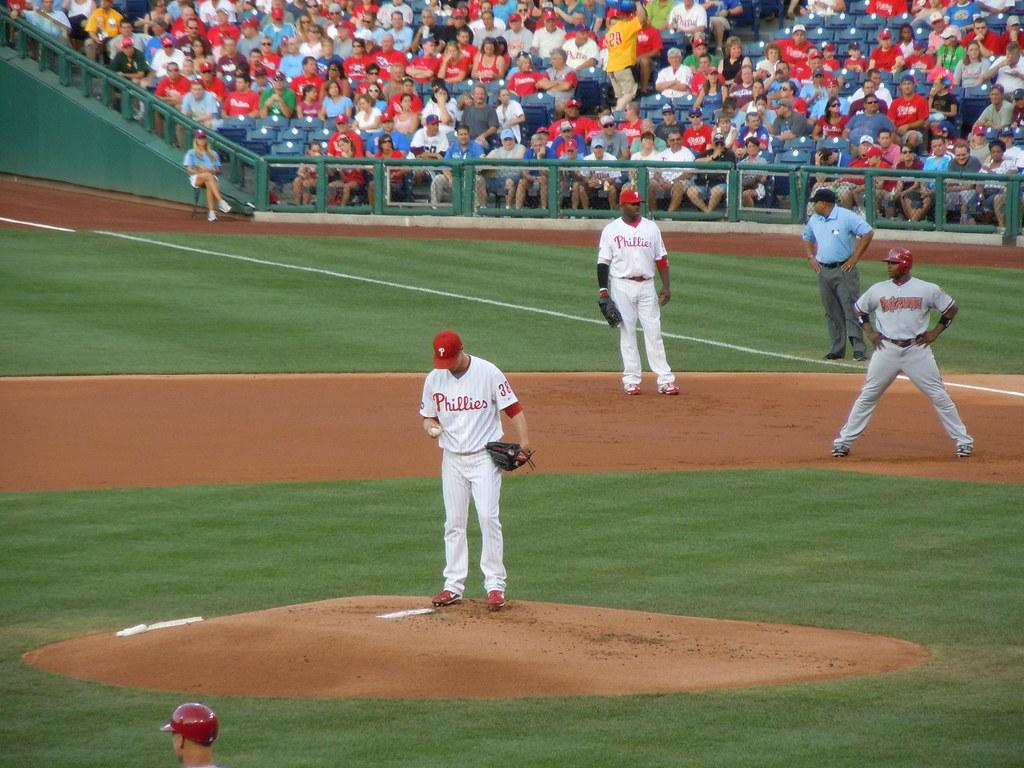Provide a one-sentence caption for the provided image. The Phillies pitcher preps for another batter as everyone looks on. 